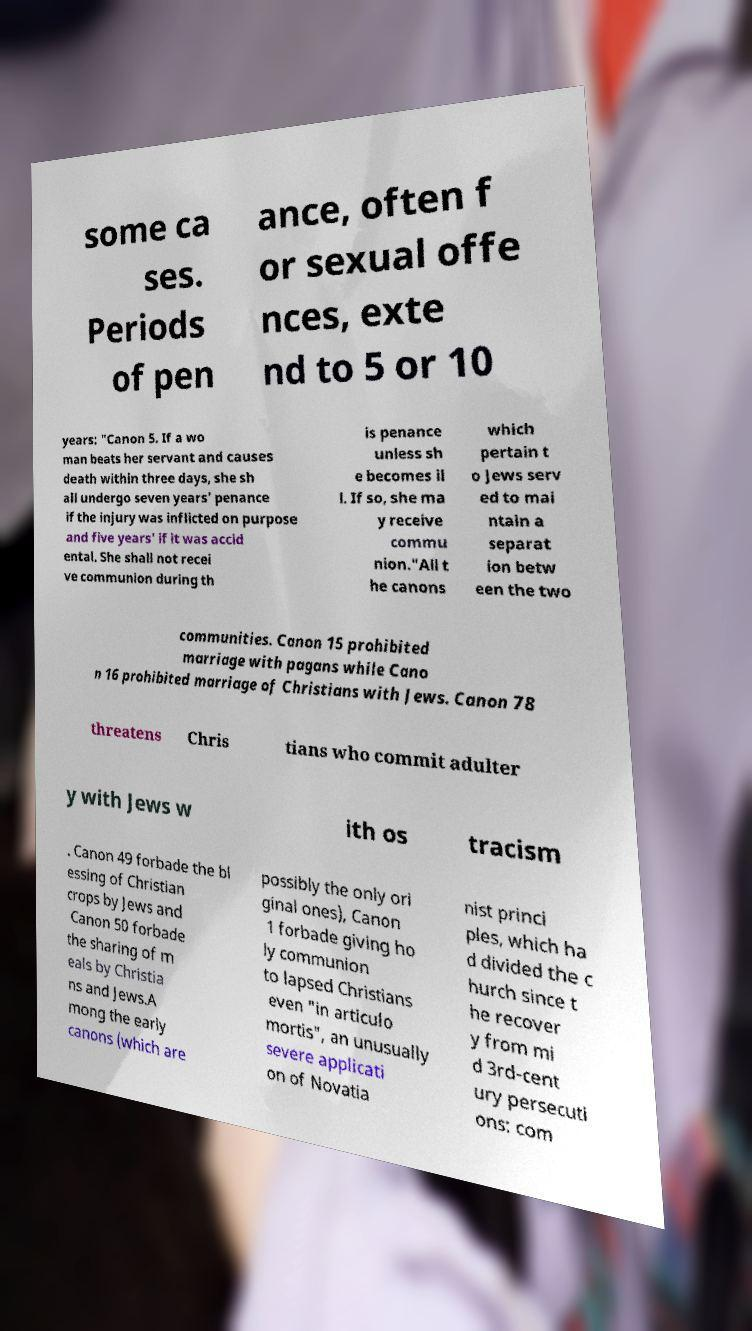Can you read and provide the text displayed in the image?This photo seems to have some interesting text. Can you extract and type it out for me? some ca ses. Periods of pen ance, often f or sexual offe nces, exte nd to 5 or 10 years: "Canon 5. If a wo man beats her servant and causes death within three days, she sh all undergo seven years' penance if the injury was inflicted on purpose and five years' if it was accid ental. She shall not recei ve communion during th is penance unless sh e becomes il l. If so, she ma y receive commu nion."All t he canons which pertain t o Jews serv ed to mai ntain a separat ion betw een the two communities. Canon 15 prohibited marriage with pagans while Cano n 16 prohibited marriage of Christians with Jews. Canon 78 threatens Chris tians who commit adulter y with Jews w ith os tracism . Canon 49 forbade the bl essing of Christian crops by Jews and Canon 50 forbade the sharing of m eals by Christia ns and Jews.A mong the early canons (which are possibly the only ori ginal ones), Canon 1 forbade giving ho ly communion to lapsed Christians even "in articulo mortis", an unusually severe applicati on of Novatia nist princi ples, which ha d divided the c hurch since t he recover y from mi d 3rd-cent ury persecuti ons: com 